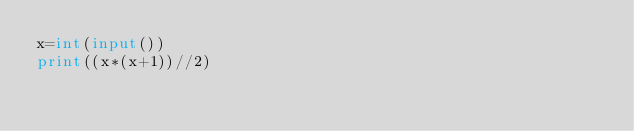<code> <loc_0><loc_0><loc_500><loc_500><_Python_>x=int(input())
print((x*(x+1))//2)</code> 